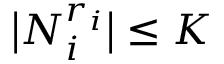<formula> <loc_0><loc_0><loc_500><loc_500>\left | N _ { i } ^ { r _ { i } } \right | \leq K</formula> 